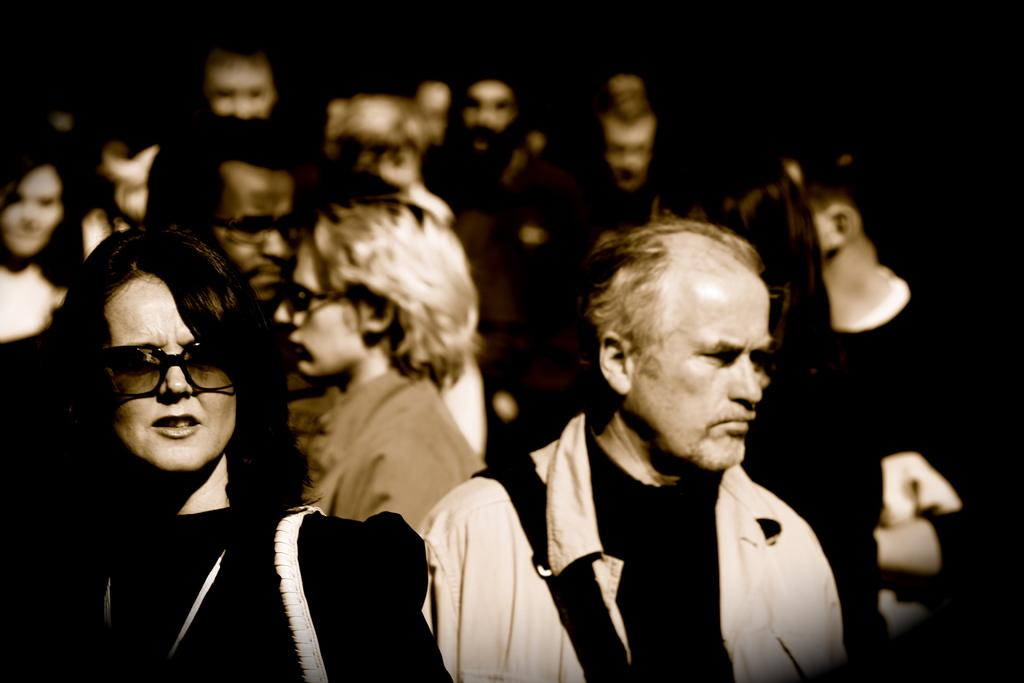How many people are in the image? There is a group of people in the image, but the exact number is not specified. What can be seen in the background of the image? The background of the image is black. What type of juice is being served in the image? There is no juice present in the image. What store can be seen in the background of the image? There is no store present in the image, as the background is black. 